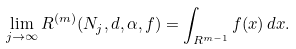<formula> <loc_0><loc_0><loc_500><loc_500>\lim _ { j \to \infty } R ^ { ( m ) } ( N _ { j } , d , \alpha , f ) = \int _ { { R } ^ { m - 1 } } f ( { x } ) \, d { x } .</formula> 